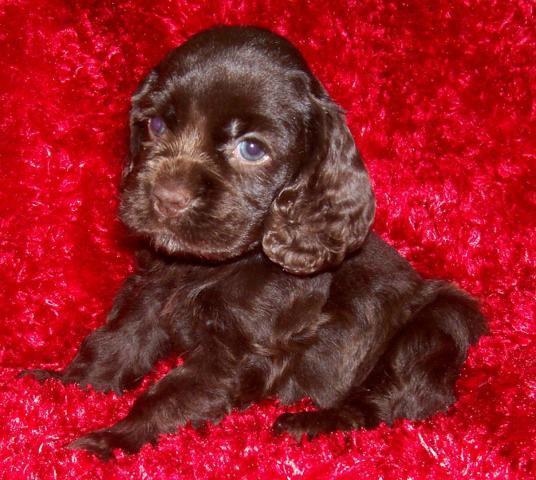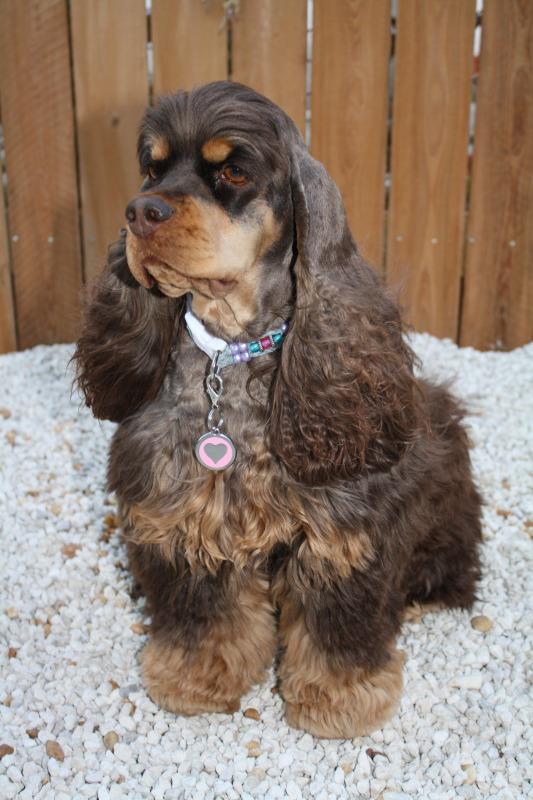The first image is the image on the left, the second image is the image on the right. Analyze the images presented: Is the assertion "Each image contains exactly one spaniel, and the dog on the left is younger than the one on the right, which wears a collar but no leash." valid? Answer yes or no. Yes. The first image is the image on the left, the second image is the image on the right. Analyze the images presented: Is the assertion "One dog is brown and white" valid? Answer yes or no. No. 